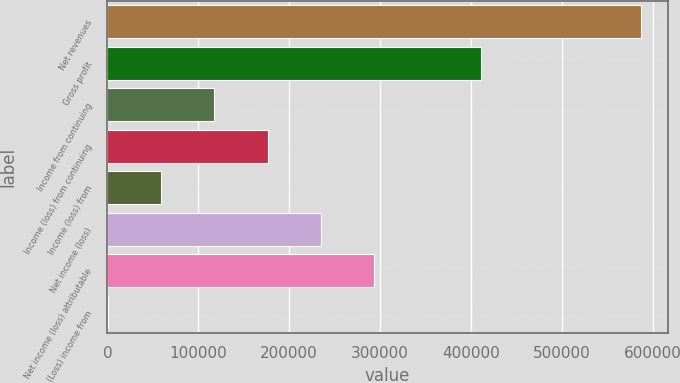<chart> <loc_0><loc_0><loc_500><loc_500><bar_chart><fcel>Net revenues<fcel>Gross profit<fcel>Income from continuing<fcel>Income (loss) from continuing<fcel>Income (loss) from<fcel>Net income (loss)<fcel>Net income (loss) attributable<fcel>(Loss) income from<nl><fcel>587230<fcel>411115<fcel>117589<fcel>176294<fcel>58884.1<fcel>234999<fcel>293704<fcel>179<nl></chart> 